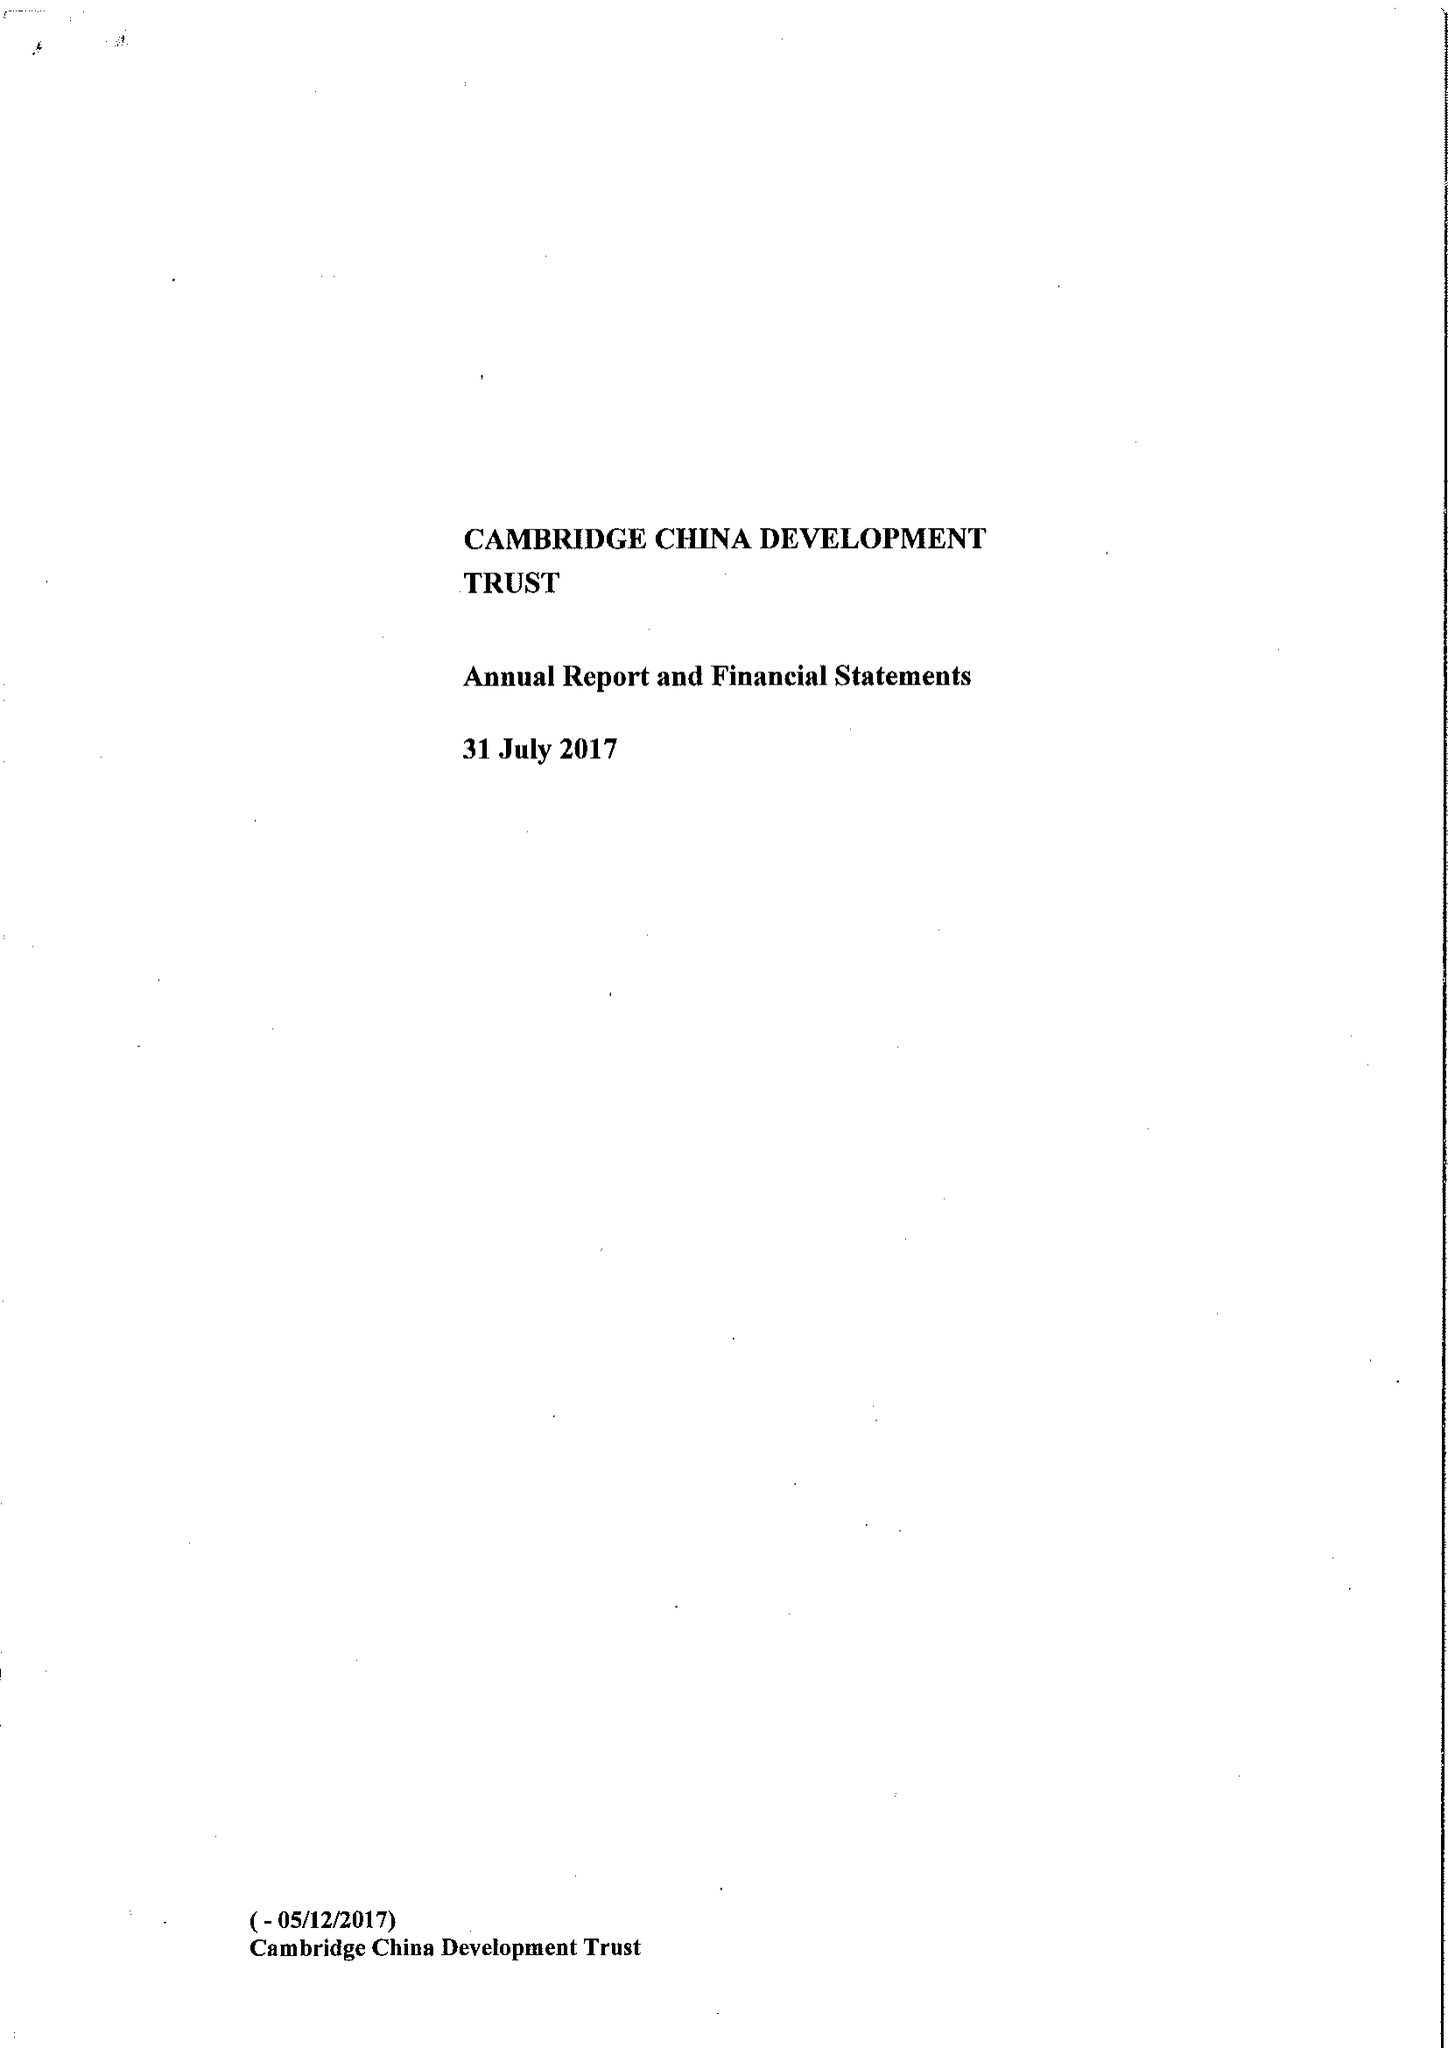What is the value for the spending_annually_in_british_pounds?
Answer the question using a single word or phrase. 514820.00 